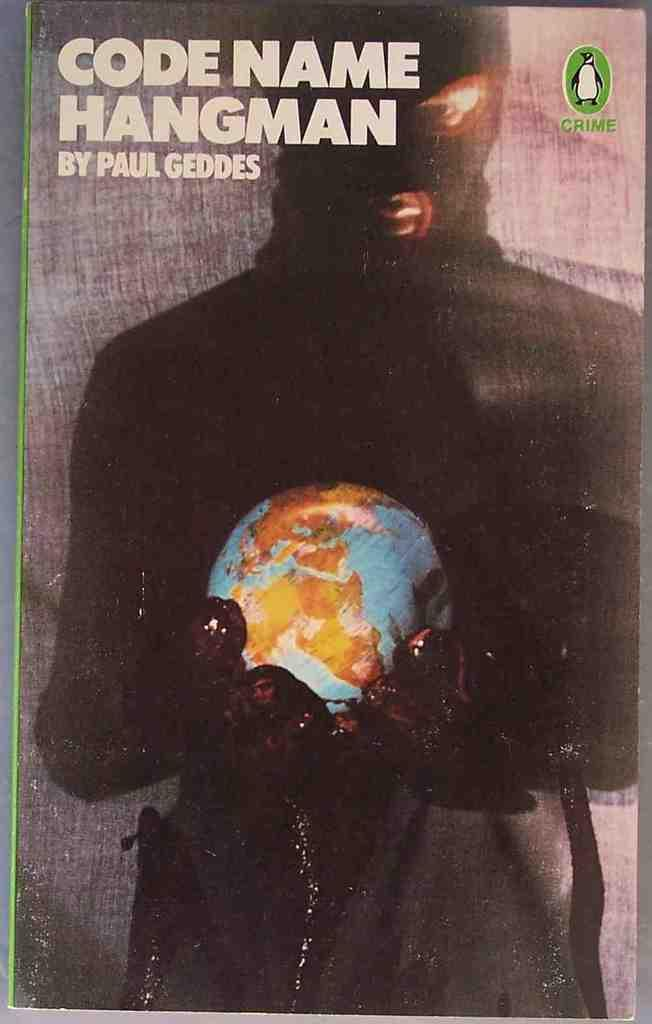<image>
Create a compact narrative representing the image presented. A book called Code Name Hangman is displayed 